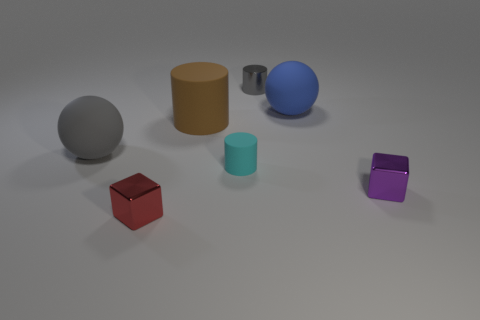Add 3 metal objects. How many objects exist? 10 Subtract all spheres. How many objects are left? 5 Add 6 large spheres. How many large spheres are left? 8 Add 4 large gray blocks. How many large gray blocks exist? 4 Subtract 1 purple cubes. How many objects are left? 6 Subtract all small gray metal objects. Subtract all purple objects. How many objects are left? 5 